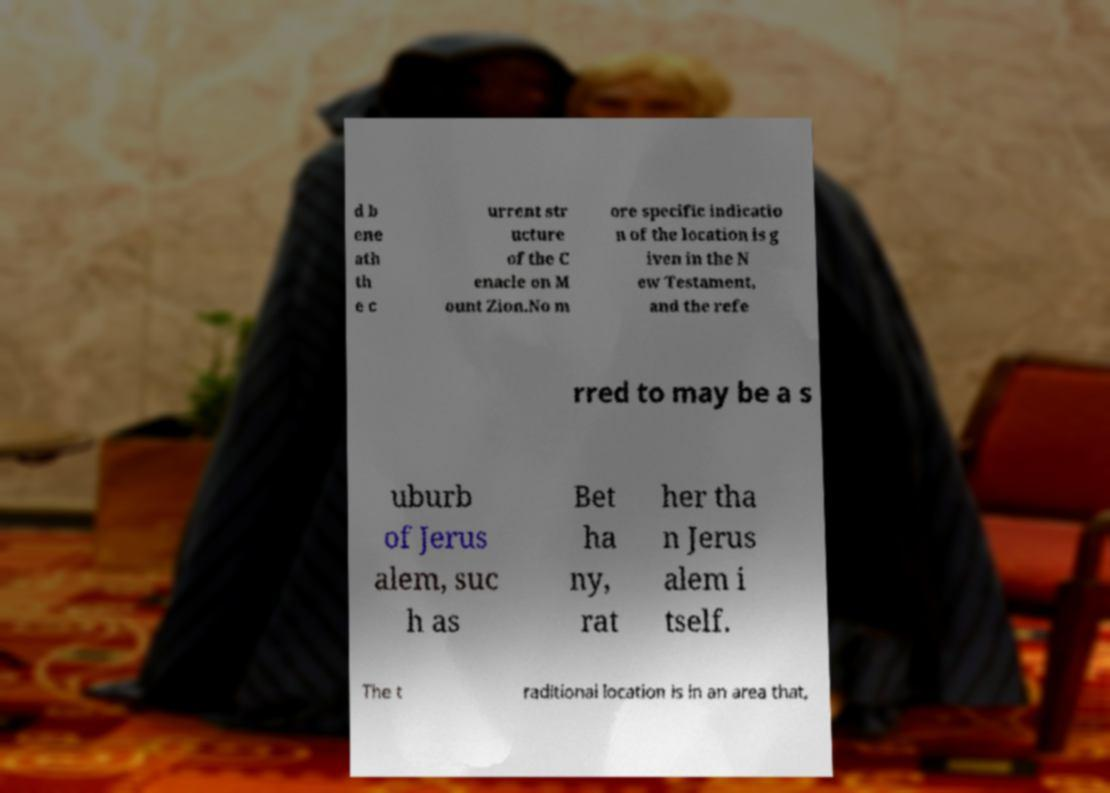I need the written content from this picture converted into text. Can you do that? d b ene ath th e c urrent str ucture of the C enacle on M ount Zion.No m ore specific indicatio n of the location is g iven in the N ew Testament, and the refe rred to may be a s uburb of Jerus alem, suc h as Bet ha ny, rat her tha n Jerus alem i tself. The t raditional location is in an area that, 